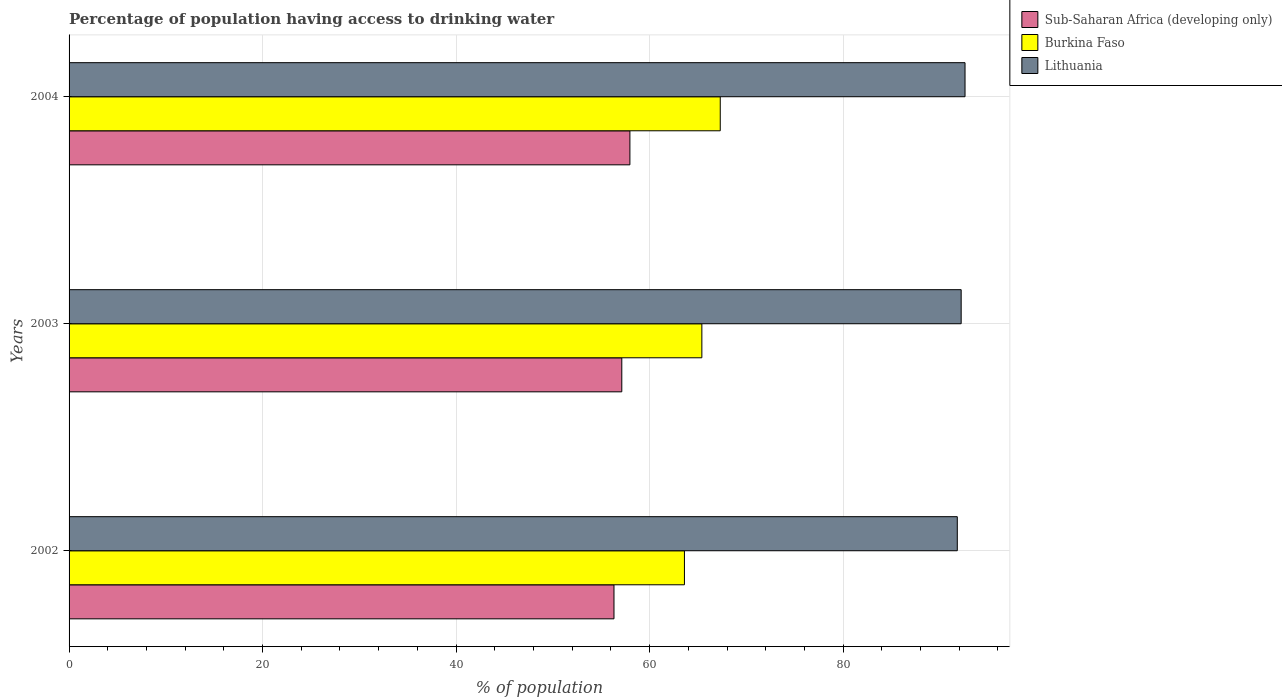How many bars are there on the 2nd tick from the bottom?
Your answer should be very brief. 3. What is the label of the 1st group of bars from the top?
Give a very brief answer. 2004. What is the percentage of population having access to drinking water in Burkina Faso in 2002?
Provide a succinct answer. 63.6. Across all years, what is the maximum percentage of population having access to drinking water in Lithuania?
Provide a short and direct response. 92.6. Across all years, what is the minimum percentage of population having access to drinking water in Lithuania?
Your response must be concise. 91.8. In which year was the percentage of population having access to drinking water in Sub-Saharan Africa (developing only) maximum?
Provide a short and direct response. 2004. In which year was the percentage of population having access to drinking water in Burkina Faso minimum?
Keep it short and to the point. 2002. What is the total percentage of population having access to drinking water in Lithuania in the graph?
Ensure brevity in your answer.  276.6. What is the difference between the percentage of population having access to drinking water in Lithuania in 2002 and that in 2003?
Offer a very short reply. -0.4. What is the difference between the percentage of population having access to drinking water in Lithuania in 2004 and the percentage of population having access to drinking water in Burkina Faso in 2002?
Offer a very short reply. 29. What is the average percentage of population having access to drinking water in Sub-Saharan Africa (developing only) per year?
Your answer should be very brief. 57.14. In the year 2002, what is the difference between the percentage of population having access to drinking water in Lithuania and percentage of population having access to drinking water in Sub-Saharan Africa (developing only)?
Provide a succinct answer. 35.48. What is the ratio of the percentage of population having access to drinking water in Burkina Faso in 2002 to that in 2003?
Give a very brief answer. 0.97. Is the percentage of population having access to drinking water in Burkina Faso in 2003 less than that in 2004?
Provide a succinct answer. Yes. Is the difference between the percentage of population having access to drinking water in Lithuania in 2003 and 2004 greater than the difference between the percentage of population having access to drinking water in Sub-Saharan Africa (developing only) in 2003 and 2004?
Keep it short and to the point. Yes. What is the difference between the highest and the second highest percentage of population having access to drinking water in Sub-Saharan Africa (developing only)?
Provide a short and direct response. 0.84. What is the difference between the highest and the lowest percentage of population having access to drinking water in Lithuania?
Give a very brief answer. 0.8. What does the 1st bar from the top in 2002 represents?
Your answer should be very brief. Lithuania. What does the 2nd bar from the bottom in 2002 represents?
Your answer should be compact. Burkina Faso. How many bars are there?
Give a very brief answer. 9. How many years are there in the graph?
Your answer should be compact. 3. Are the values on the major ticks of X-axis written in scientific E-notation?
Offer a terse response. No. How many legend labels are there?
Ensure brevity in your answer.  3. What is the title of the graph?
Offer a very short reply. Percentage of population having access to drinking water. Does "Iceland" appear as one of the legend labels in the graph?
Give a very brief answer. No. What is the label or title of the X-axis?
Your answer should be compact. % of population. What is the % of population in Sub-Saharan Africa (developing only) in 2002?
Offer a terse response. 56.32. What is the % of population of Burkina Faso in 2002?
Provide a succinct answer. 63.6. What is the % of population of Lithuania in 2002?
Provide a succinct answer. 91.8. What is the % of population in Sub-Saharan Africa (developing only) in 2003?
Ensure brevity in your answer.  57.12. What is the % of population of Burkina Faso in 2003?
Offer a terse response. 65.4. What is the % of population in Lithuania in 2003?
Provide a short and direct response. 92.2. What is the % of population in Sub-Saharan Africa (developing only) in 2004?
Your response must be concise. 57.96. What is the % of population in Burkina Faso in 2004?
Offer a terse response. 67.3. What is the % of population of Lithuania in 2004?
Offer a very short reply. 92.6. Across all years, what is the maximum % of population of Sub-Saharan Africa (developing only)?
Your response must be concise. 57.96. Across all years, what is the maximum % of population of Burkina Faso?
Your answer should be very brief. 67.3. Across all years, what is the maximum % of population in Lithuania?
Ensure brevity in your answer.  92.6. Across all years, what is the minimum % of population in Sub-Saharan Africa (developing only)?
Ensure brevity in your answer.  56.32. Across all years, what is the minimum % of population in Burkina Faso?
Your response must be concise. 63.6. Across all years, what is the minimum % of population in Lithuania?
Keep it short and to the point. 91.8. What is the total % of population in Sub-Saharan Africa (developing only) in the graph?
Provide a short and direct response. 171.41. What is the total % of population of Burkina Faso in the graph?
Make the answer very short. 196.3. What is the total % of population of Lithuania in the graph?
Give a very brief answer. 276.6. What is the difference between the % of population of Sub-Saharan Africa (developing only) in 2002 and that in 2003?
Provide a short and direct response. -0.81. What is the difference between the % of population of Lithuania in 2002 and that in 2003?
Give a very brief answer. -0.4. What is the difference between the % of population in Sub-Saharan Africa (developing only) in 2002 and that in 2004?
Provide a succinct answer. -1.64. What is the difference between the % of population in Burkina Faso in 2002 and that in 2004?
Provide a succinct answer. -3.7. What is the difference between the % of population of Sub-Saharan Africa (developing only) in 2003 and that in 2004?
Give a very brief answer. -0.84. What is the difference between the % of population in Burkina Faso in 2003 and that in 2004?
Offer a terse response. -1.9. What is the difference between the % of population of Lithuania in 2003 and that in 2004?
Offer a terse response. -0.4. What is the difference between the % of population in Sub-Saharan Africa (developing only) in 2002 and the % of population in Burkina Faso in 2003?
Ensure brevity in your answer.  -9.08. What is the difference between the % of population in Sub-Saharan Africa (developing only) in 2002 and the % of population in Lithuania in 2003?
Keep it short and to the point. -35.88. What is the difference between the % of population of Burkina Faso in 2002 and the % of population of Lithuania in 2003?
Ensure brevity in your answer.  -28.6. What is the difference between the % of population in Sub-Saharan Africa (developing only) in 2002 and the % of population in Burkina Faso in 2004?
Make the answer very short. -10.98. What is the difference between the % of population in Sub-Saharan Africa (developing only) in 2002 and the % of population in Lithuania in 2004?
Keep it short and to the point. -36.28. What is the difference between the % of population of Burkina Faso in 2002 and the % of population of Lithuania in 2004?
Provide a succinct answer. -29. What is the difference between the % of population of Sub-Saharan Africa (developing only) in 2003 and the % of population of Burkina Faso in 2004?
Make the answer very short. -10.18. What is the difference between the % of population of Sub-Saharan Africa (developing only) in 2003 and the % of population of Lithuania in 2004?
Give a very brief answer. -35.48. What is the difference between the % of population in Burkina Faso in 2003 and the % of population in Lithuania in 2004?
Ensure brevity in your answer.  -27.2. What is the average % of population of Sub-Saharan Africa (developing only) per year?
Your answer should be very brief. 57.14. What is the average % of population in Burkina Faso per year?
Keep it short and to the point. 65.43. What is the average % of population in Lithuania per year?
Offer a terse response. 92.2. In the year 2002, what is the difference between the % of population of Sub-Saharan Africa (developing only) and % of population of Burkina Faso?
Offer a terse response. -7.28. In the year 2002, what is the difference between the % of population of Sub-Saharan Africa (developing only) and % of population of Lithuania?
Give a very brief answer. -35.48. In the year 2002, what is the difference between the % of population of Burkina Faso and % of population of Lithuania?
Your answer should be very brief. -28.2. In the year 2003, what is the difference between the % of population in Sub-Saharan Africa (developing only) and % of population in Burkina Faso?
Provide a short and direct response. -8.28. In the year 2003, what is the difference between the % of population of Sub-Saharan Africa (developing only) and % of population of Lithuania?
Your answer should be very brief. -35.08. In the year 2003, what is the difference between the % of population in Burkina Faso and % of population in Lithuania?
Provide a short and direct response. -26.8. In the year 2004, what is the difference between the % of population in Sub-Saharan Africa (developing only) and % of population in Burkina Faso?
Provide a short and direct response. -9.34. In the year 2004, what is the difference between the % of population in Sub-Saharan Africa (developing only) and % of population in Lithuania?
Give a very brief answer. -34.64. In the year 2004, what is the difference between the % of population of Burkina Faso and % of population of Lithuania?
Your response must be concise. -25.3. What is the ratio of the % of population in Sub-Saharan Africa (developing only) in 2002 to that in 2003?
Provide a short and direct response. 0.99. What is the ratio of the % of population in Burkina Faso in 2002 to that in 2003?
Keep it short and to the point. 0.97. What is the ratio of the % of population of Sub-Saharan Africa (developing only) in 2002 to that in 2004?
Provide a short and direct response. 0.97. What is the ratio of the % of population in Burkina Faso in 2002 to that in 2004?
Your response must be concise. 0.94. What is the ratio of the % of population in Lithuania in 2002 to that in 2004?
Your answer should be compact. 0.99. What is the ratio of the % of population in Sub-Saharan Africa (developing only) in 2003 to that in 2004?
Give a very brief answer. 0.99. What is the ratio of the % of population in Burkina Faso in 2003 to that in 2004?
Keep it short and to the point. 0.97. What is the difference between the highest and the second highest % of population in Sub-Saharan Africa (developing only)?
Your response must be concise. 0.84. What is the difference between the highest and the lowest % of population in Sub-Saharan Africa (developing only)?
Offer a terse response. 1.64. What is the difference between the highest and the lowest % of population of Lithuania?
Ensure brevity in your answer.  0.8. 